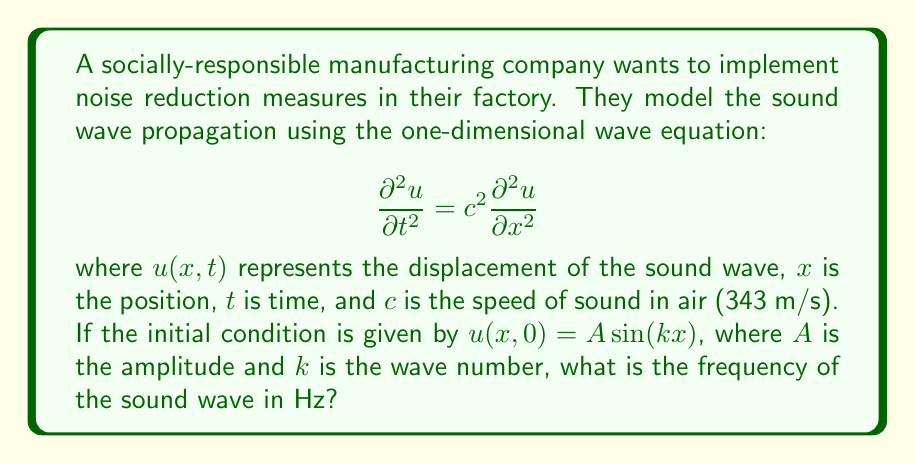Show me your answer to this math problem. To find the frequency of the sound wave, we need to follow these steps:

1) The general solution to the one-dimensional wave equation is:

   $$u(x,t) = f(x-ct) + g(x+ct)$$

   where $f$ and $g$ are arbitrary functions.

2) Given the initial condition $u(x,0) = A \sin(kx)$, we can deduce that the solution takes the form:

   $$u(x,t) = A \sin(kx - \omega t)$$

   where $\omega$ is the angular frequency.

3) Substituting this solution into the wave equation:

   $$\frac{\partial^2 u}{\partial t^2} = \omega^2 A \sin(kx - \omega t) = c^2 \frac{\partial^2 u}{\partial x^2} = c^2 k^2 A \sin(kx - \omega t)$$

4) For this to be true for all $x$ and $t$, we must have:

   $$\omega^2 = c^2 k^2$$

5) Solving for $\omega$:

   $$\omega = ck$$

6) The relationship between angular frequency $\omega$ and frequency $f$ in Hz is:

   $$\omega = 2\pi f$$

7) Therefore:

   $$f = \frac{\omega}{2\pi} = \frac{ck}{2\pi}$$

8) The wave number $k$ is related to the wavelength $\lambda$ by:

   $$k = \frac{2\pi}{\lambda}$$

9) Substituting this into our frequency equation:

   $$f = \frac{c}{\lambda}$$

This is the well-known relationship between frequency, speed, and wavelength for waves.
Answer: $f = \frac{c}{\lambda}$ 